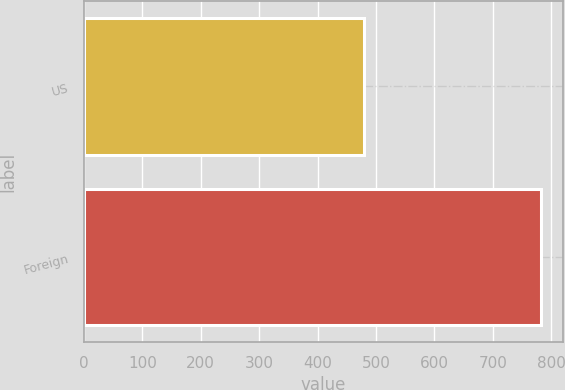Convert chart to OTSL. <chart><loc_0><loc_0><loc_500><loc_500><bar_chart><fcel>US<fcel>Foreign<nl><fcel>479<fcel>782<nl></chart> 